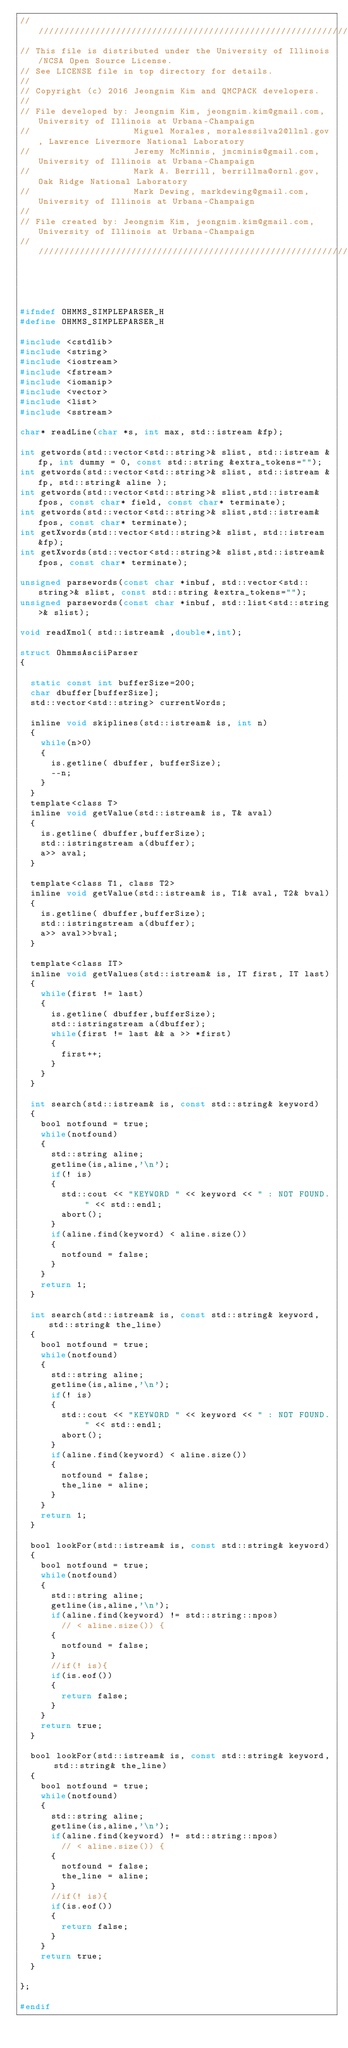<code> <loc_0><loc_0><loc_500><loc_500><_C_>//////////////////////////////////////////////////////////////////////////////////////
// This file is distributed under the University of Illinois/NCSA Open Source License.
// See LICENSE file in top directory for details.
//
// Copyright (c) 2016 Jeongnim Kim and QMCPACK developers.
//
// File developed by: Jeongnim Kim, jeongnim.kim@gmail.com, University of Illinois at Urbana-Champaign
//                    Miguel Morales, moralessilva2@llnl.gov, Lawrence Livermore National Laboratory
//                    Jeremy McMinnis, jmcminis@gmail.com, University of Illinois at Urbana-Champaign
//                    Mark A. Berrill, berrillma@ornl.gov, Oak Ridge National Laboratory
//                    Mark Dewing, markdewing@gmail.com, University of Illinois at Urbana-Champaign
//
// File created by: Jeongnim Kim, jeongnim.kim@gmail.com, University of Illinois at Urbana-Champaign
//////////////////////////////////////////////////////////////////////////////////////
    
    


#ifndef OHMMS_SIMPLEPARSER_H
#define OHMMS_SIMPLEPARSER_H

#include <cstdlib>
#include <string>
#include <iostream>
#include <fstream>
#include <iomanip>
#include <vector>
#include <list>
#include <sstream>

char* readLine(char *s, int max, std::istream &fp);

int getwords(std::vector<std::string>& slist, std::istream &fp, int dummy = 0, const std::string &extra_tokens="");
int getwords(std::vector<std::string>& slist, std::istream &fp, std::string& aline );
int getwords(std::vector<std::string>& slist,std::istream& fpos, const char* field, const char* terminate);
int getwords(std::vector<std::string>& slist,std::istream& fpos, const char* terminate);
int getXwords(std::vector<std::string>& slist, std::istream &fp);
int getXwords(std::vector<std::string>& slist,std::istream& fpos, const char* terminate);

unsigned parsewords(const char *inbuf, std::vector<std::string>& slist, const std::string &extra_tokens="");
unsigned parsewords(const char *inbuf, std::list<std::string>& slist);

void readXmol( std::istream& ,double*,int);

struct OhmmsAsciiParser
{

  static const int bufferSize=200;
  char dbuffer[bufferSize];
  std::vector<std::string> currentWords;

  inline void skiplines(std::istream& is, int n)
  {
    while(n>0)
    {
      is.getline( dbuffer, bufferSize);
      --n;
    }
  }
  template<class T>
  inline void getValue(std::istream& is, T& aval)
  {
    is.getline( dbuffer,bufferSize);
    std::istringstream a(dbuffer);
    a>> aval;
  }

  template<class T1, class T2>
  inline void getValue(std::istream& is, T1& aval, T2& bval)
  {
    is.getline( dbuffer,bufferSize);
    std::istringstream a(dbuffer);
    a>> aval>>bval;
  }

  template<class IT>
  inline void getValues(std::istream& is, IT first, IT last)
  {
    while(first != last)
    {
      is.getline( dbuffer,bufferSize);
      std::istringstream a(dbuffer);
      while(first != last && a >> *first)
      {
        first++;
      }
    }
  }

  int search(std::istream& is, const std::string& keyword)
  {
    bool notfound = true;
    while(notfound)
    {
      std::string aline;
      getline(is,aline,'\n');
      if(! is)
      {
        std::cout << "KEYWORD " << keyword << " : NOT FOUND. " << std::endl;
        abort();
      }
      if(aline.find(keyword) < aline.size())
      {
        notfound = false;
      }
    }
    return 1;
  }

  int search(std::istream& is, const std::string& keyword, std::string& the_line)
  {
    bool notfound = true;
    while(notfound)
    {
      std::string aline;
      getline(is,aline,'\n');
      if(! is)
      {
        std::cout << "KEYWORD " << keyword << " : NOT FOUND. " << std::endl;
        abort();
      }
      if(aline.find(keyword) < aline.size())
      {
        notfound = false;
        the_line = aline;
      }
    }
    return 1;
  }

  bool lookFor(std::istream& is, const std::string& keyword)
  {
    bool notfound = true;
    while(notfound)
    {
      std::string aline;
      getline(is,aline,'\n');
      if(aline.find(keyword) != std::string::npos)
        // < aline.size()) {
      {
        notfound = false;
      }
      //if(! is){
      if(is.eof())
      {
        return false;
      }
    }
    return true;
  }

  bool lookFor(std::istream& is, const std::string& keyword, std::string& the_line)
  {
    bool notfound = true;
    while(notfound)
    {
      std::string aline;
      getline(is,aline,'\n');
      if(aline.find(keyword) != std::string::npos)
        // < aline.size()) {
      {
        notfound = false;
        the_line = aline;
      }
      //if(! is){
      if(is.eof())
      {
        return false;
      }
    }
    return true;
  }

};

#endif

</code> 